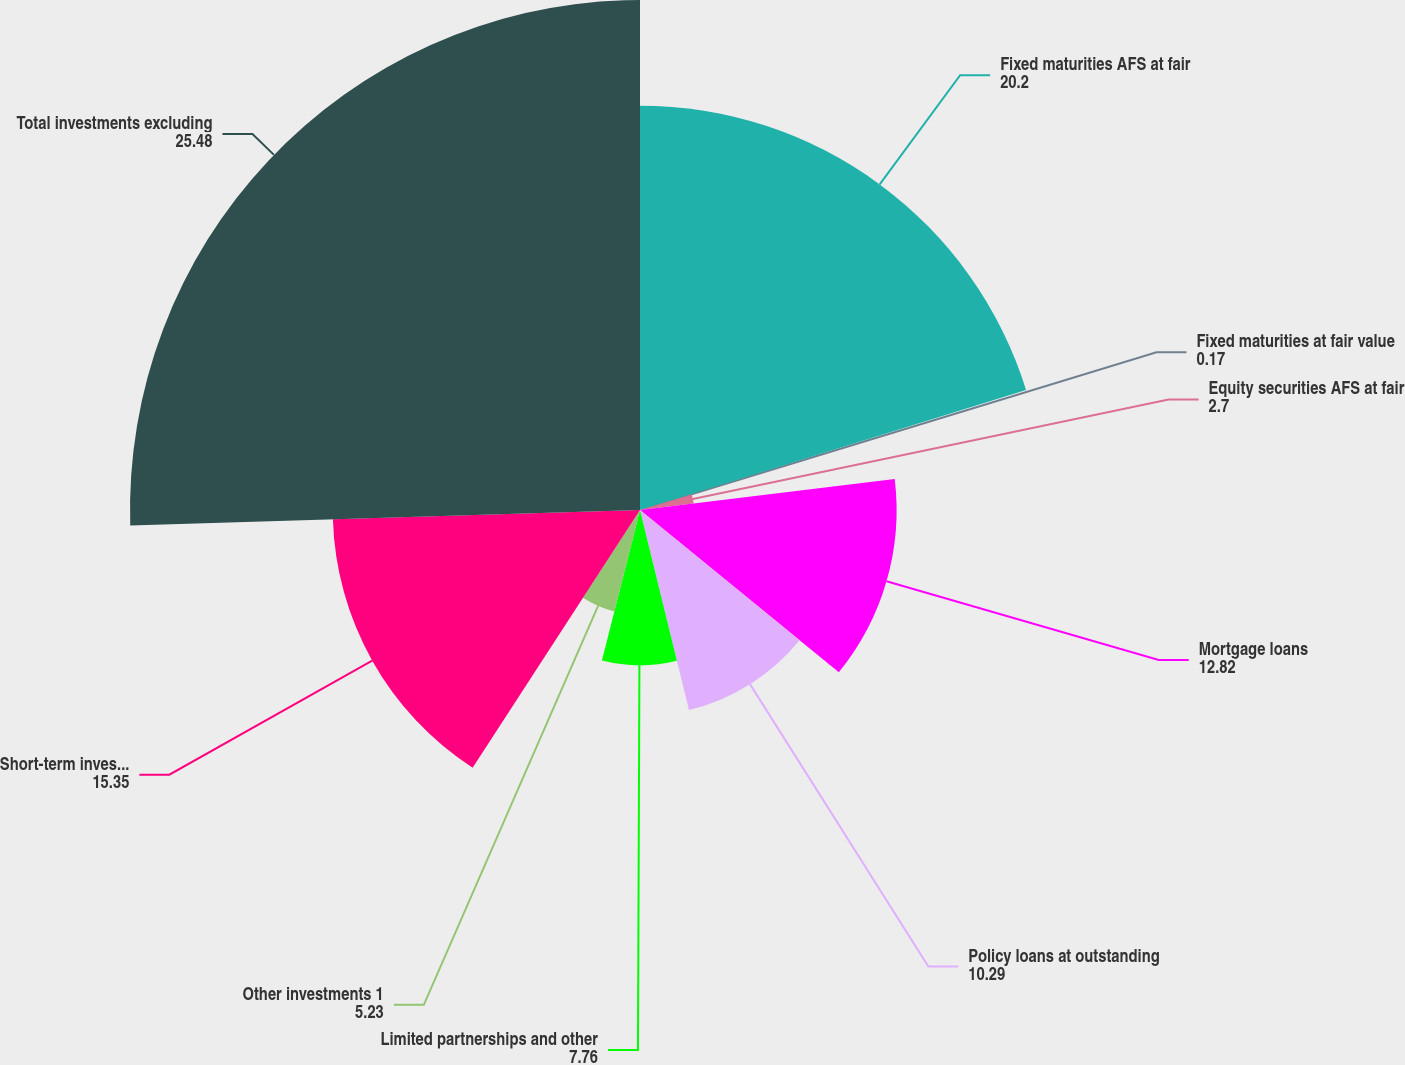Convert chart. <chart><loc_0><loc_0><loc_500><loc_500><pie_chart><fcel>Fixed maturities AFS at fair<fcel>Fixed maturities at fair value<fcel>Equity securities AFS at fair<fcel>Mortgage loans<fcel>Policy loans at outstanding<fcel>Limited partnerships and other<fcel>Other investments 1<fcel>Short-term investments<fcel>Total investments excluding<nl><fcel>20.2%<fcel>0.17%<fcel>2.7%<fcel>12.82%<fcel>10.29%<fcel>7.76%<fcel>5.23%<fcel>15.35%<fcel>25.48%<nl></chart> 